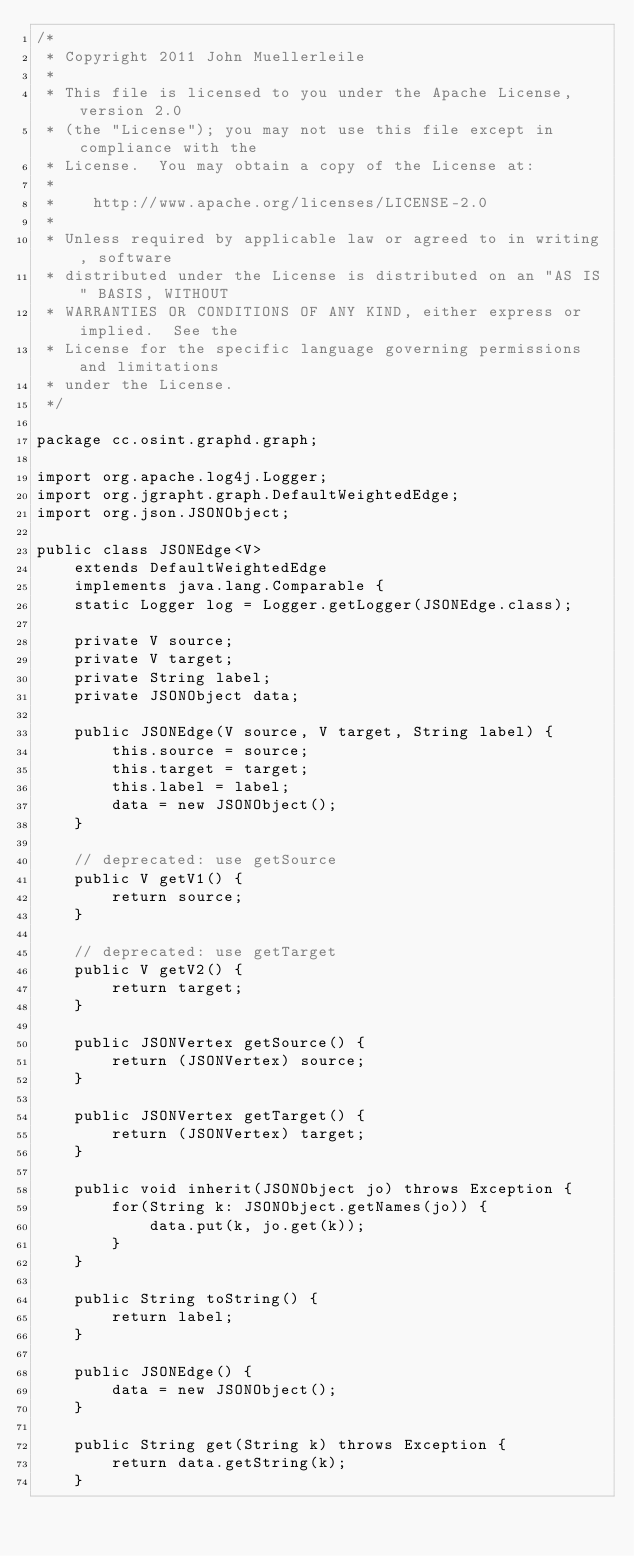Convert code to text. <code><loc_0><loc_0><loc_500><loc_500><_Java_>/*
 * Copyright 2011 John Muellerleile
 *
 * This file is licensed to you under the Apache License, version 2.0
 * (the "License"); you may not use this file except in compliance with the
 * License.  You may obtain a copy of the License at:
 *
 *    http://www.apache.org/licenses/LICENSE-2.0
 *
 * Unless required by applicable law or agreed to in writing, software
 * distributed under the License is distributed on an "AS IS" BASIS, WITHOUT
 * WARRANTIES OR CONDITIONS OF ANY KIND, either express or implied.  See the
 * License for the specific language governing permissions and limitations
 * under the License.
 */

package cc.osint.graphd.graph;

import org.apache.log4j.Logger;
import org.jgrapht.graph.DefaultWeightedEdge;
import org.json.JSONObject;

public class JSONEdge<V> 
    extends DefaultWeightedEdge 
    implements java.lang.Comparable {
    static Logger log = Logger.getLogger(JSONEdge.class);

    private V source;
    private V target;
    private String label;
    private JSONObject data;

    public JSONEdge(V source, V target, String label) {
        this.source = source;
        this.target = target;
        this.label = label;
        data = new JSONObject();
    }

    // deprecated: use getSource
    public V getV1() {
        return source;
    }

    // deprecated: use getTarget
    public V getV2() {
        return target;
    }
    
    public JSONVertex getSource() {
        return (JSONVertex) source;
    }
    
    public JSONVertex getTarget() {
        return (JSONVertex) target;
    }
    
    public void inherit(JSONObject jo) throws Exception {
        for(String k: JSONObject.getNames(jo)) {
            data.put(k, jo.get(k));
        }
    }

    public String toString() {
        return label;
    }

    public JSONEdge() {
        data = new JSONObject();
    }

    public String get(String k) throws Exception {
        return data.getString(k);
    }
    </code> 